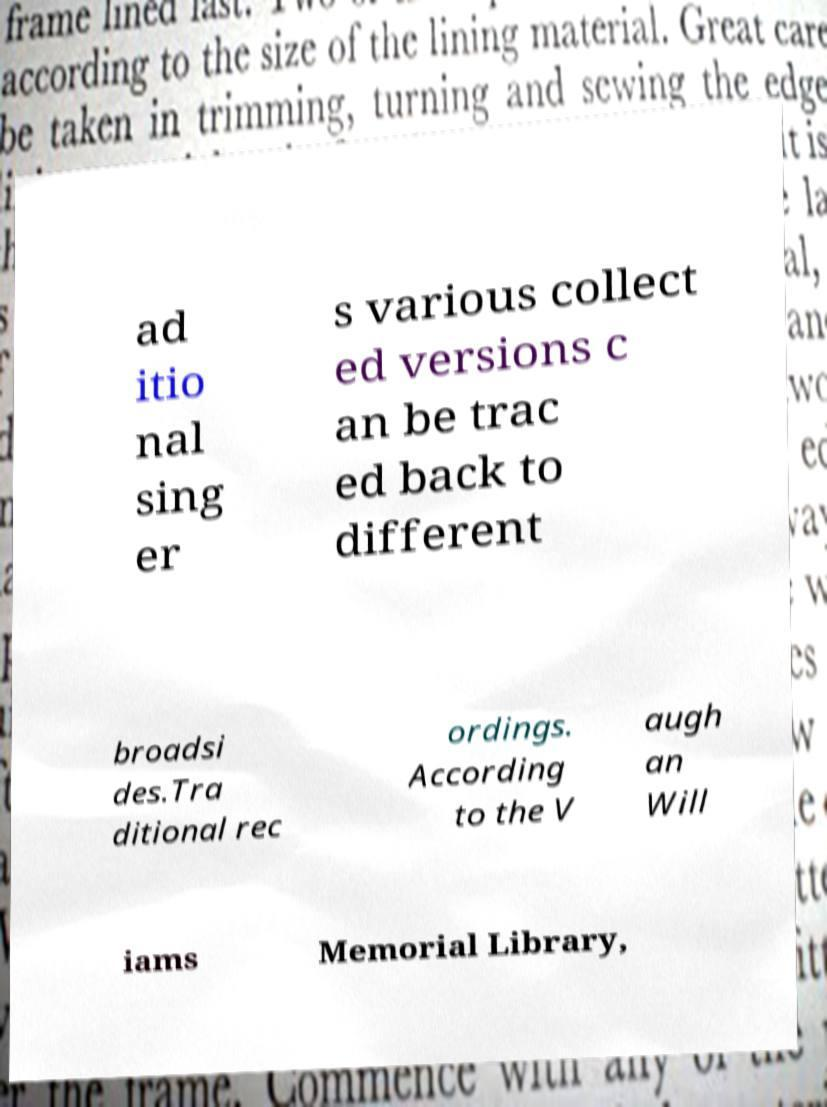Could you assist in decoding the text presented in this image and type it out clearly? ad itio nal sing er s various collect ed versions c an be trac ed back to different broadsi des.Tra ditional rec ordings. According to the V augh an Will iams Memorial Library, 